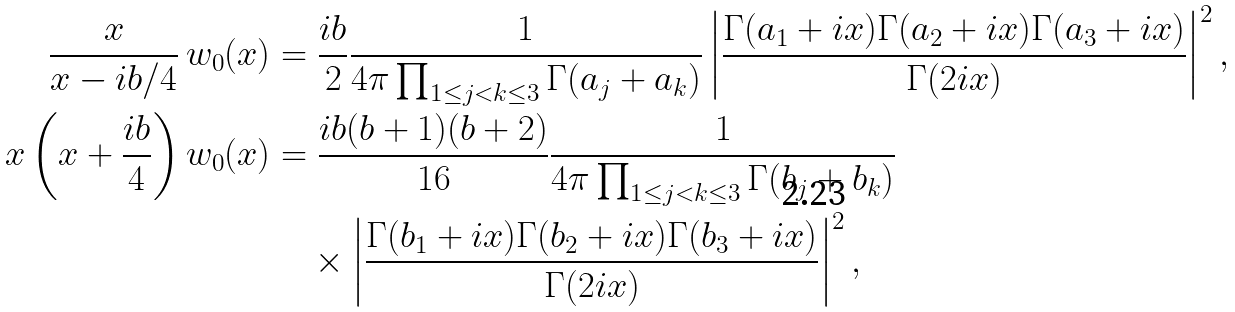Convert formula to latex. <formula><loc_0><loc_0><loc_500><loc_500>\frac { x } { x - i b / 4 } \, w _ { 0 } ( x ) & = \frac { i b } { 2 } \frac { 1 } { 4 \pi \prod _ { 1 \leq j < k \leq 3 } \Gamma ( a _ { j } + a _ { k } ) } \left | \frac { \Gamma ( a _ { 1 } + i x ) \Gamma ( a _ { 2 } + i x ) \Gamma ( a _ { 3 } + i x ) } { \Gamma ( 2 i x ) } \right | ^ { 2 } , \\ x \left ( x + \frac { i b } 4 \right ) w _ { 0 } ( x ) & = \frac { i b ( b + 1 ) ( b + 2 ) } { 1 6 } \frac { 1 } { 4 \pi \prod _ { 1 \leq j < k \leq 3 } \Gamma ( b _ { j } + b _ { k } ) } \\ & \quad \times \left | \frac { \Gamma ( b _ { 1 } + i x ) \Gamma ( b _ { 2 } + i x ) \Gamma ( b _ { 3 } + i x ) } { \Gamma ( 2 i x ) } \right | ^ { 2 } ,</formula> 